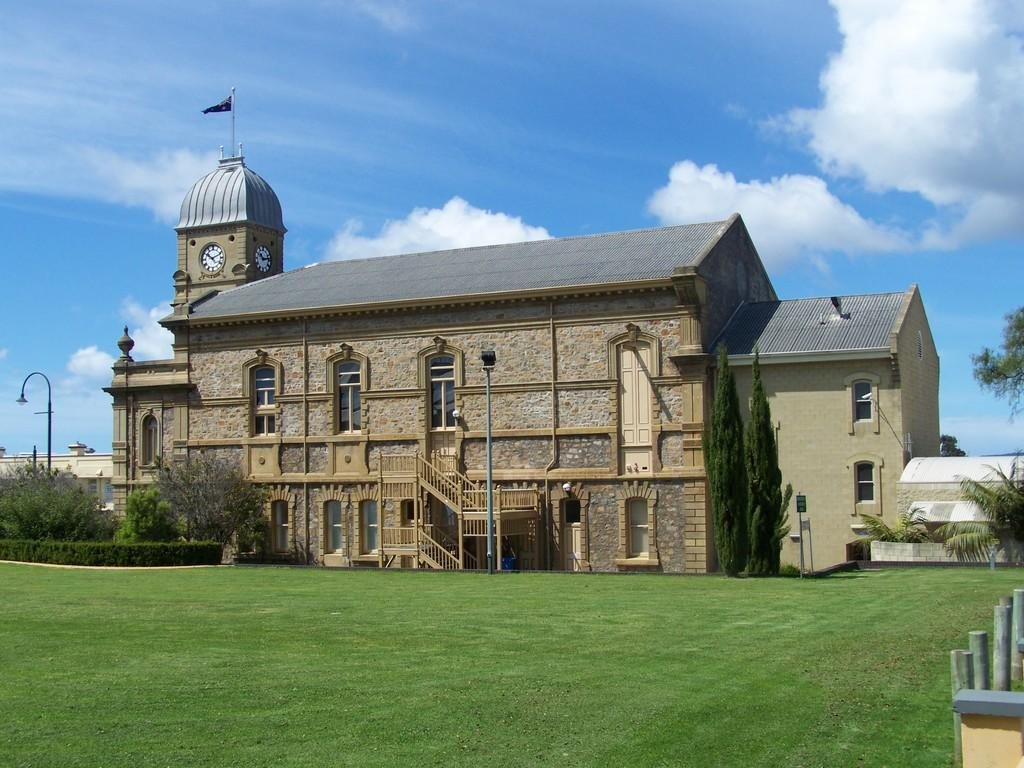What type of vegetation can be seen in the image? There is grass, trees, and shrubs in the image. Can you describe any architectural features in the image? Yes, there is a staircase, a stone house, and a clock tower in the image. What is the color of the sky in the background? The sky is blue in the background. Are there any additional objects visible in the image? Yes, there are light poles and a flag in the image. What can be seen in the background besides the sky? There are clouds in the background. Can you tell me who won the argument between the bat and the sneeze in the image? There is no argument, bat, or sneeze present in the image. 